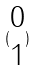Convert formula to latex. <formula><loc_0><loc_0><loc_500><loc_500>( \begin{matrix} 0 \\ 1 \end{matrix} )</formula> 